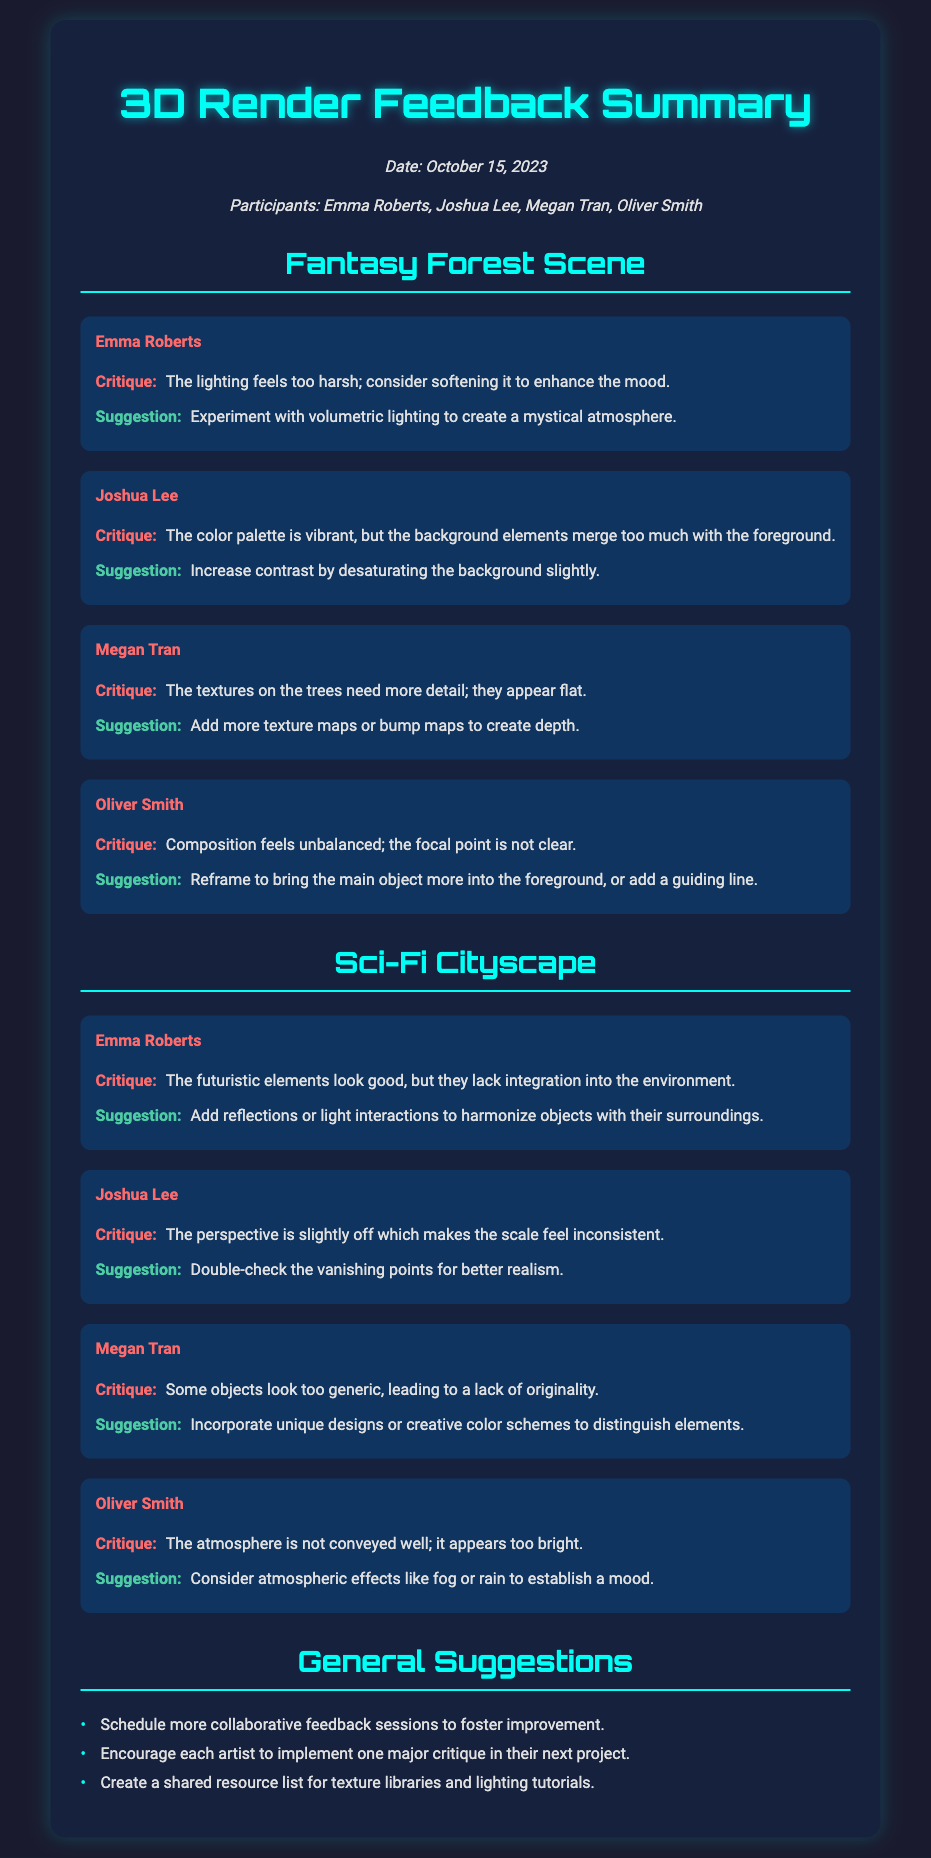What date was the feedback session held? The date of the feedback session is mentioned clearly in the document.
Answer: October 15, 2023 Who provided feedback on the Fantasy Forest Scene? The document lists all participants who provided feedback for the specific scene.
Answer: Emma Roberts, Joshua Lee, Megan Tran, Oliver Smith What critique did Megan Tran provide for the Fantasy Forest Scene? Megan Tran's specific critique regarding the Fantasy Forest Scene is highlighted in the document.
Answer: The textures on the trees need more detail; they appear flat What suggestion did Joshua Lee make for the Sci-Fi Cityscape? Joshua Lee's suggestion for the Sci-Fi Cityscape is listed in the document.
Answer: Double-check the vanishing points for better realism Which suggestion is listed under General Suggestions? The document includes a list of general suggestions for future improvement.
Answer: Schedule more collaborative feedback sessions to foster improvement 